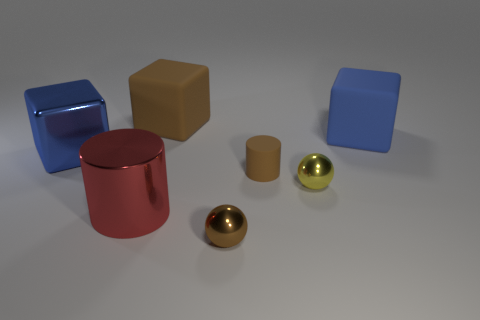Add 2 large red metallic things. How many objects exist? 9 Subtract all blocks. How many objects are left? 4 Add 5 large cylinders. How many large cylinders exist? 6 Subtract 0 purple blocks. How many objects are left? 7 Subtract all large shiny things. Subtract all red metallic cylinders. How many objects are left? 4 Add 5 small brown metallic things. How many small brown metallic things are left? 6 